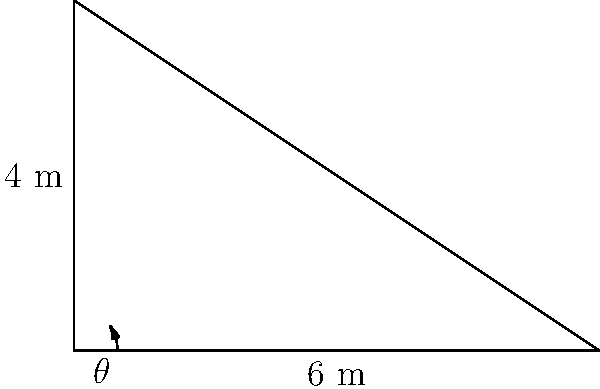As a former news presenter who covered many on-location stories, you're familiar with setting up equipment for broadcasts. A new radio tower has been erected in your town, and you're curious about its height. On a sunny day, you notice that the tower casts a shadow 6 meters long. If the angle of elevation of the sun is 33.7°, what is the height of the radio tower to the nearest tenth of a meter? Let's approach this step-by-step:

1) In this problem, we have a right triangle formed by the radio tower, its shadow, and the sun's rays.

2) We know:
   - The length of the shadow (adjacent side) = 6 meters
   - The angle of elevation of the sun = 33.7°

3) We need to find the height of the tower, which is the opposite side in this right triangle.

4) This is a perfect scenario to use the tangent trigonometric function. Recall that:

   $\tan(\theta) = \frac{\text{opposite}}{\text{adjacent}}$

5) In our case:
   $\tan(33.7°) = \frac{\text{height}}{\text{shadow length}}$

6) Let's plug in the values:
   $\tan(33.7°) = \frac{\text{height}}{6}$

7) To solve for the height, multiply both sides by 6:
   $6 \cdot \tan(33.7°) = \text{height}$

8) Now, let's calculate:
   $\text{height} = 6 \cdot \tan(33.7°) \approx 6 \cdot 0.6664 \approx 3.9984$ meters

9) Rounding to the nearest tenth:
   $\text{height} \approx 4.0$ meters
Answer: 4.0 meters 